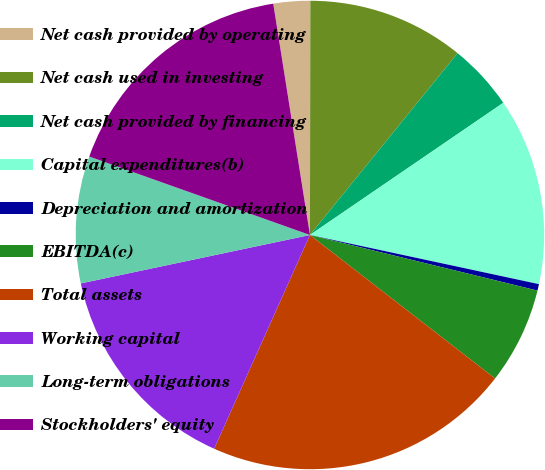Convert chart. <chart><loc_0><loc_0><loc_500><loc_500><pie_chart><fcel>Net cash provided by operating<fcel>Net cash used in investing<fcel>Net cash provided by financing<fcel>Capital expenditures(b)<fcel>Depreciation and amortization<fcel>EBITDA(c)<fcel>Total assets<fcel>Working capital<fcel>Long-term obligations<fcel>Stockholders' equity<nl><fcel>2.53%<fcel>10.83%<fcel>4.6%<fcel>12.91%<fcel>0.45%<fcel>6.68%<fcel>21.21%<fcel>14.98%<fcel>8.75%<fcel>17.06%<nl></chart> 